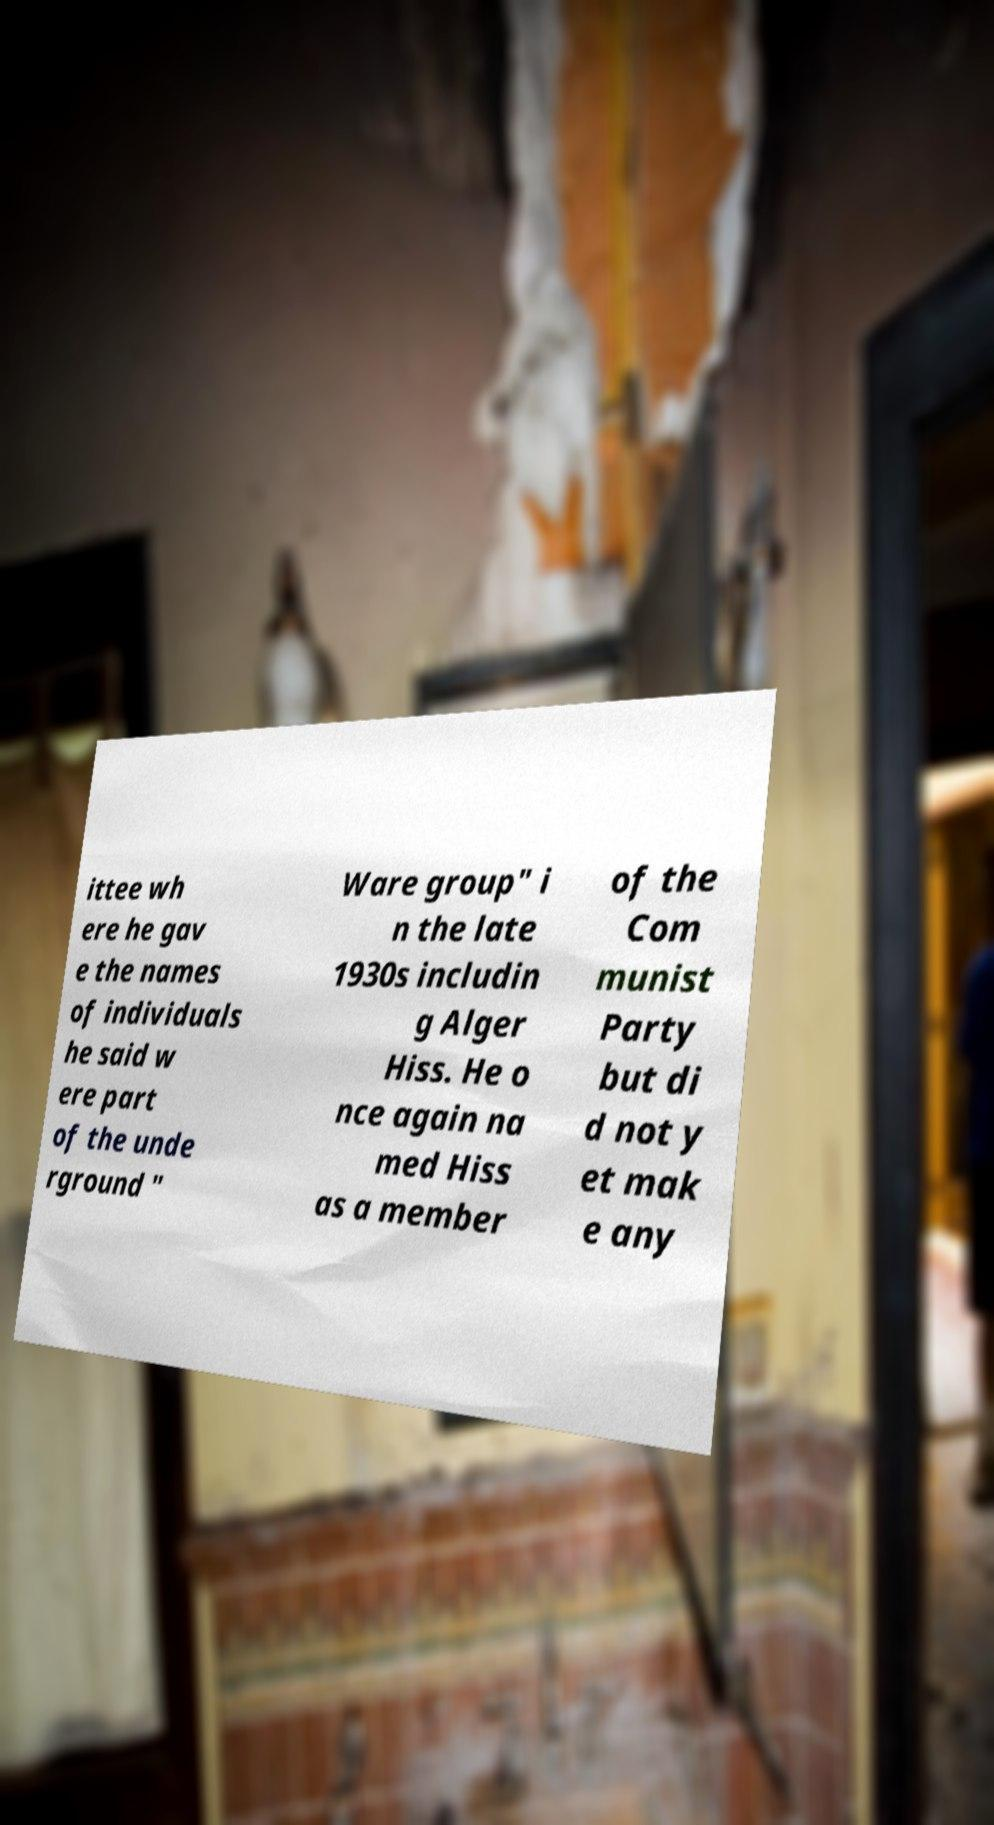Could you assist in decoding the text presented in this image and type it out clearly? ittee wh ere he gav e the names of individuals he said w ere part of the unde rground " Ware group" i n the late 1930s includin g Alger Hiss. He o nce again na med Hiss as a member of the Com munist Party but di d not y et mak e any 